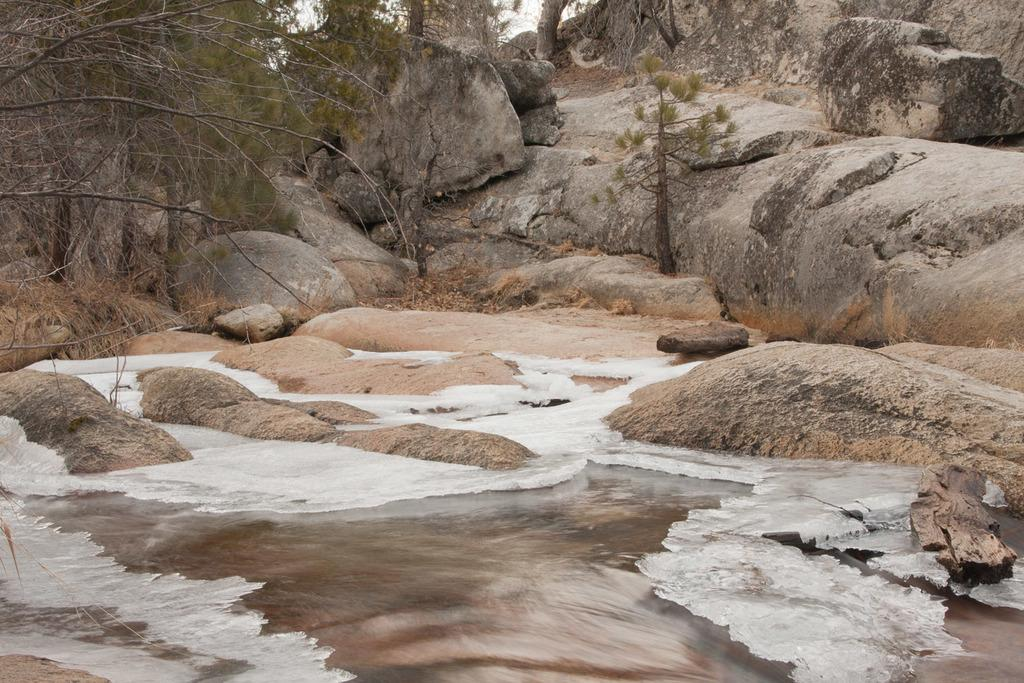What is present in the image that is related to water? There is water in the image, and there is also ice on the water. What can be seen on the top left of the image? There is a tree on the top left of the image. What is visible in the background of the image? In the background, there are trees, rocks on a hill, and the sky. What type of shoes are visible in the image? There are no shoes present in the image. 